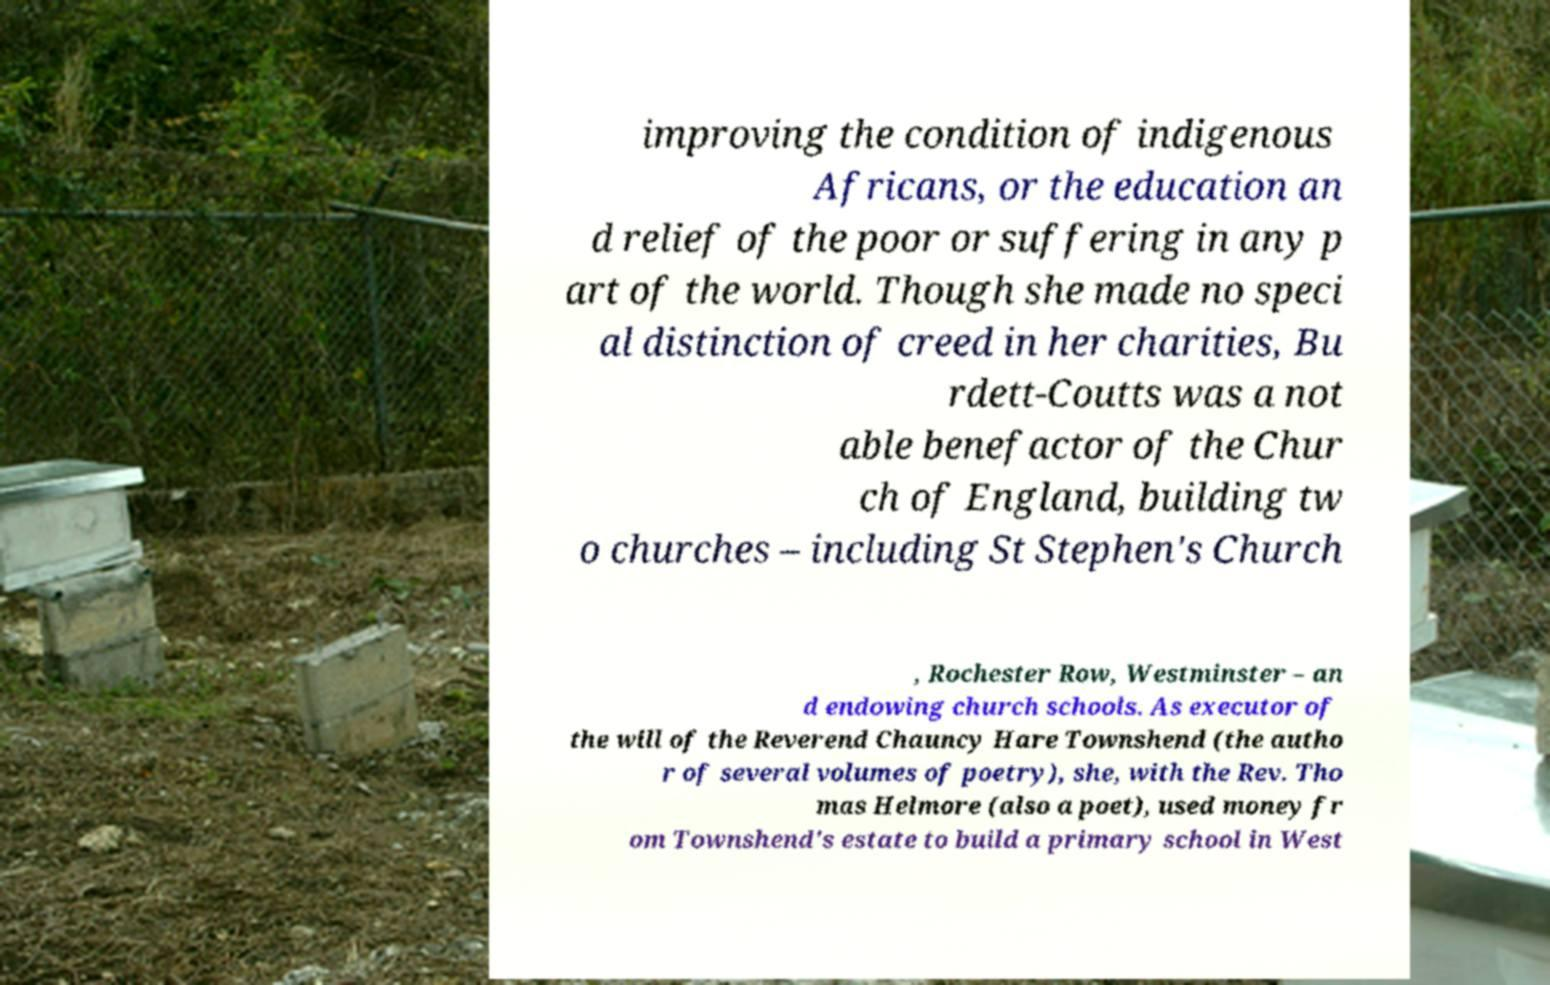Can you accurately transcribe the text from the provided image for me? improving the condition of indigenous Africans, or the education an d relief of the poor or suffering in any p art of the world. Though she made no speci al distinction of creed in her charities, Bu rdett-Coutts was a not able benefactor of the Chur ch of England, building tw o churches – including St Stephen's Church , Rochester Row, Westminster – an d endowing church schools. As executor of the will of the Reverend Chauncy Hare Townshend (the autho r of several volumes of poetry), she, with the Rev. Tho mas Helmore (also a poet), used money fr om Townshend's estate to build a primary school in West 